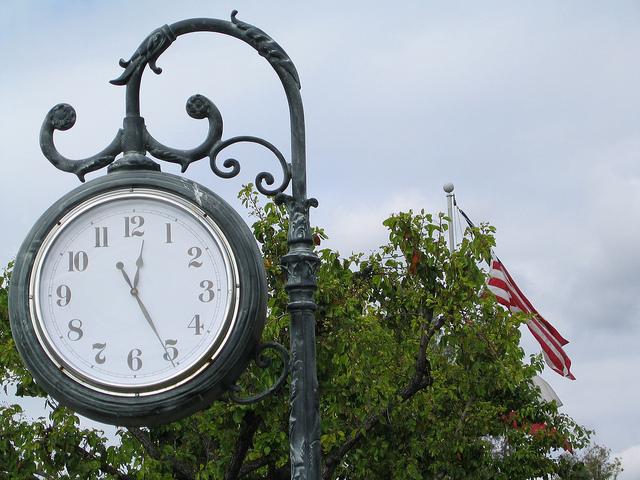What color is the clock?
Write a very short answer. White. What flag is hanging in the background?
Concise answer only. American. What is the time?
Be succinct. 12:25. What object is in the background?
Be succinct. Flag. Is this photo colorful?
Give a very brief answer. Yes. Is there concrete in this picture?
Write a very short answer. No. What color is the sky?
Short answer required. Gray. 